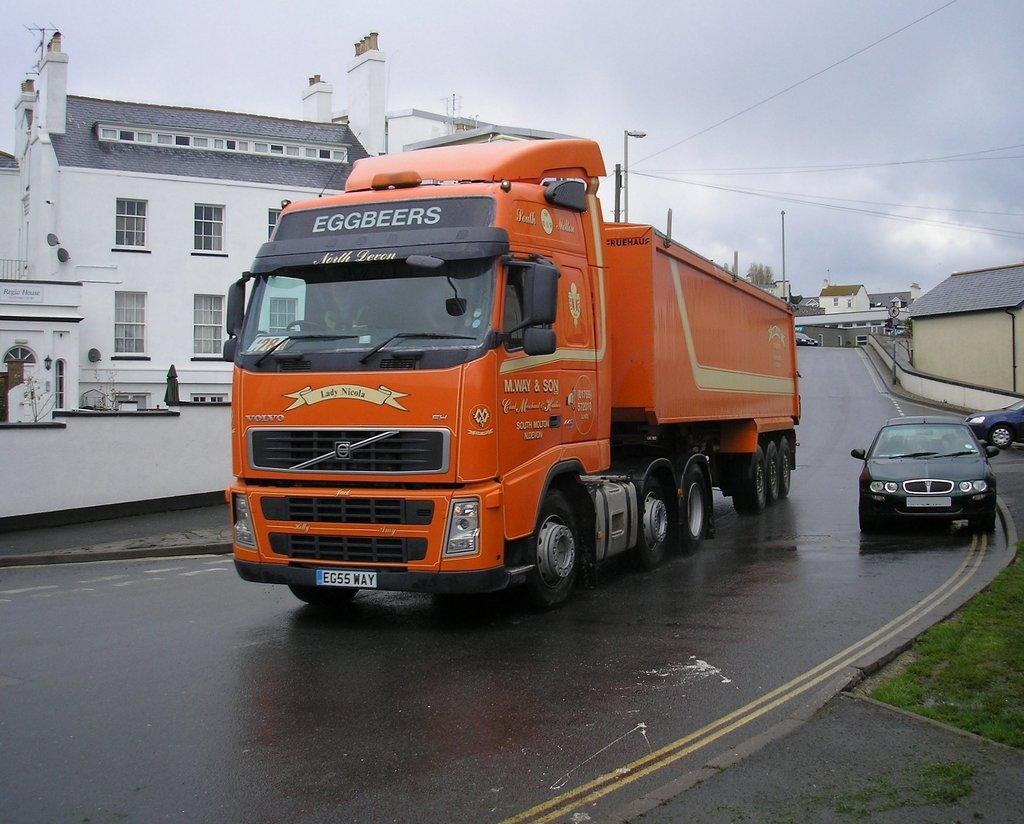What can be seen on the road in the image? There are vehicles on the road in the image. What is visible in the background of the image? There are buildings, poles, wires, and the sky visible in the background of the image. Can you tell me how many fish are swimming in the sky in the image? There are no fish present in the image, and the sky is not a body of water where fish would swim. What subject is being taught in the image? There is no teaching or educational activity depicted in the image. 